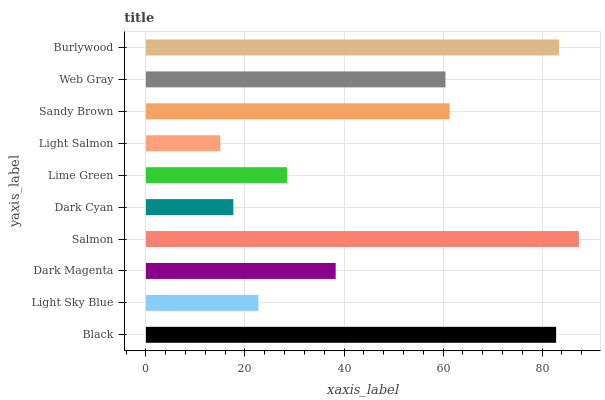Is Light Salmon the minimum?
Answer yes or no. Yes. Is Salmon the maximum?
Answer yes or no. Yes. Is Light Sky Blue the minimum?
Answer yes or no. No. Is Light Sky Blue the maximum?
Answer yes or no. No. Is Black greater than Light Sky Blue?
Answer yes or no. Yes. Is Light Sky Blue less than Black?
Answer yes or no. Yes. Is Light Sky Blue greater than Black?
Answer yes or no. No. Is Black less than Light Sky Blue?
Answer yes or no. No. Is Web Gray the high median?
Answer yes or no. Yes. Is Dark Magenta the low median?
Answer yes or no. Yes. Is Salmon the high median?
Answer yes or no. No. Is Light Sky Blue the low median?
Answer yes or no. No. 